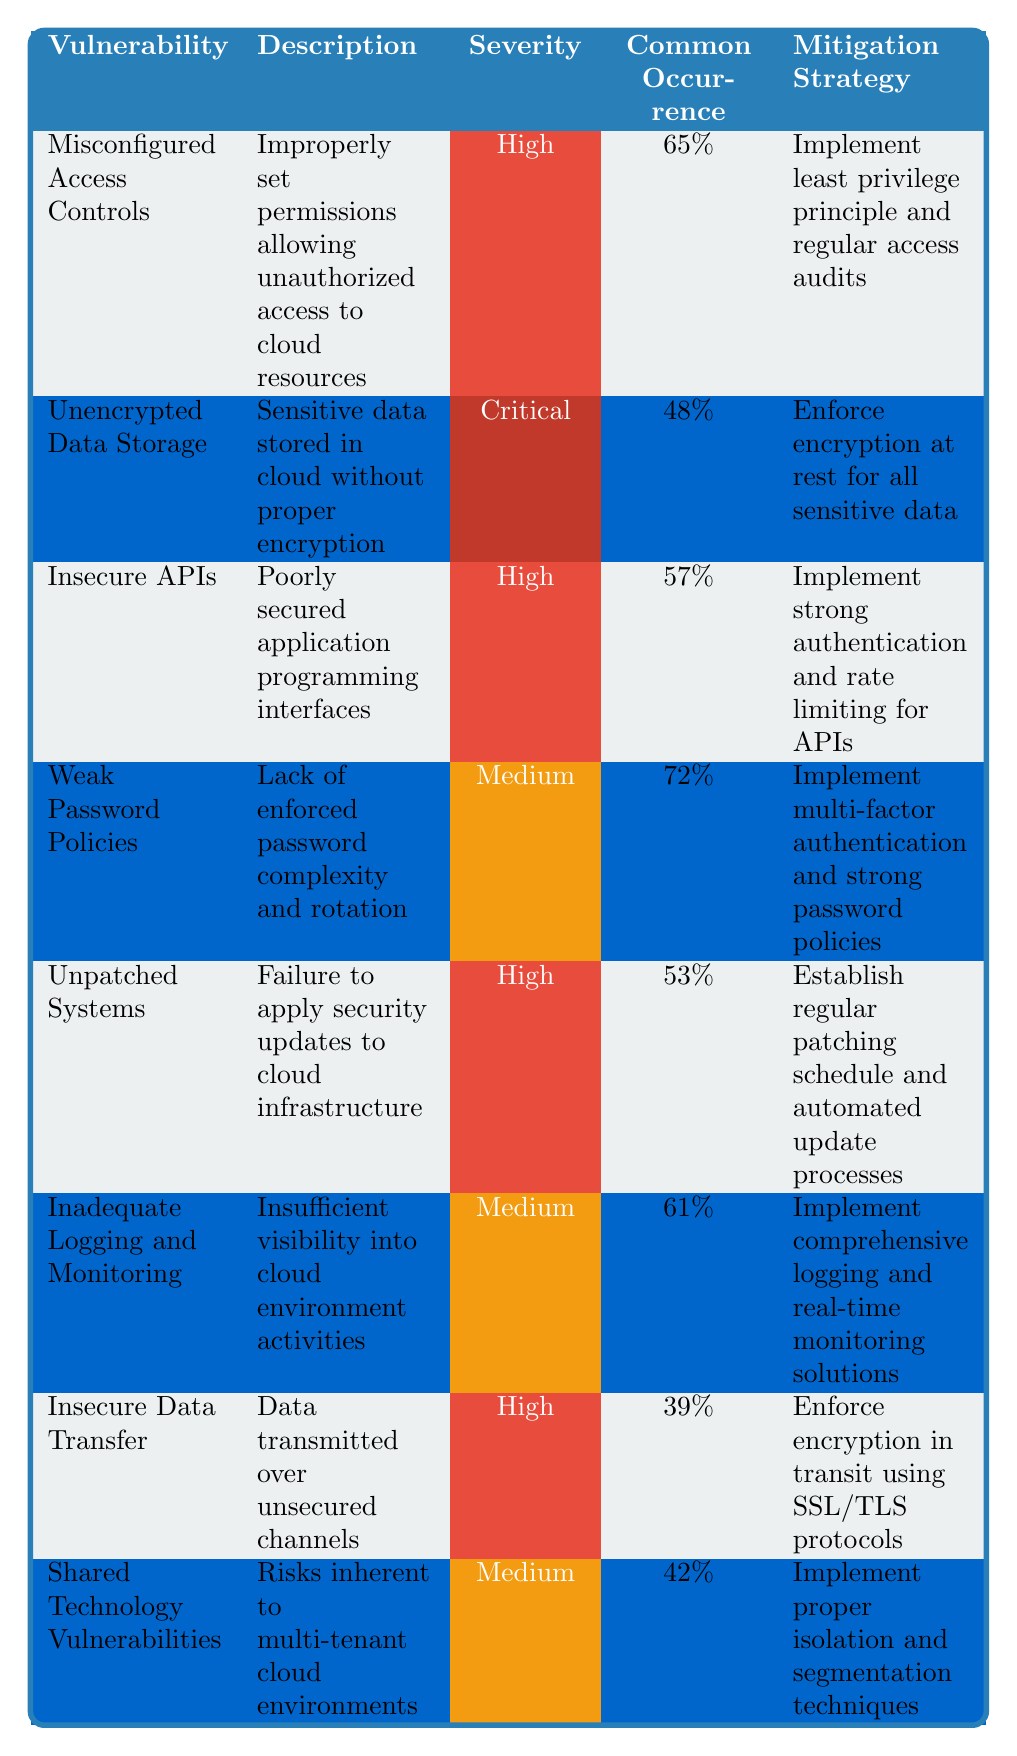What is the severity level of "Unpatched Systems"? The severity level is indicated in the table, where "Unpatched Systems" has a severity rating marked as "High".
Answer: High What percentage of common occurrence is associated with "Weak Password Policies"? The occurrence rate for "Weak Password Policies" is listed in the table as 72%.
Answer: 72% Is "Insecure Data Transfer" considered a critical vulnerability? "Insecure Data Transfer" is marked with a severity of "High" in the table, not "Critical". Therefore, the statement is false.
Answer: No Which vulnerability has the highest occurrence percentage? By comparing all the occurrence percentages in the table, "Weak Password Policies" holds the highest percentage at 72%.
Answer: 72% What mitigation strategy is recommended for "Inadequate Logging and Monitoring"? The mitigation strategy for "Inadequate Logging and Monitoring" is to "Implement comprehensive logging and real-time monitoring solutions". This is directly referenced in the table.
Answer: Implement comprehensive logging and real-time monitoring solutions How many vulnerabilities listed have a "High" severity rating? The table shows that three vulnerabilities: "Misconfigured Access Controls", "Insecure APIs", and "Unpatched Systems" have a severity rating of "High". Therefore, the total is three.
Answer: 3 Which vulnerability has the lowest occurrence percentage? Looking at the occurrence rates, "Insecure Data Transfer" has the lowest occurrence percentage at 39%.
Answer: 39% What is the common occurrence percentage of "Unencrypted Data Storage"? The table specifies that "Unencrypted Data Storage" has a common occurrence percentage of 48%.
Answer: 48% Are there more vulnerabilities with "Medium" severity than those with "Critical"? The table lists two vulnerabilities with "Medium" severity ("Weak Password Policies" and "Shared Technology Vulnerabilities") and one with "Critical" severity ("Unencrypted Data Storage"), confirming the statement true.
Answer: Yes List the mitigation strategies for vulnerabilities with "High" severity rating. The table shows the following strategies for vulnerabilities with "High" severity: 1. "Implement least privilege principle and regular access audits" for "Misconfigured Access Controls", 2. "Implement strong authentication and rate limiting for APIs" for "Insecure APIs", and 3. "Establish regular patching schedule and automated update processes" for "Unpatched Systems".
Answer: 1. Implement least privilege principle and regular access audits; 2. Implement strong authentication and rate limiting for APIs; 3. Establish regular patching schedule and automated update processes 